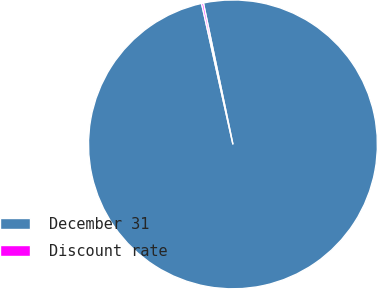Convert chart. <chart><loc_0><loc_0><loc_500><loc_500><pie_chart><fcel>December 31<fcel>Discount rate<nl><fcel>99.79%<fcel>0.21%<nl></chart> 